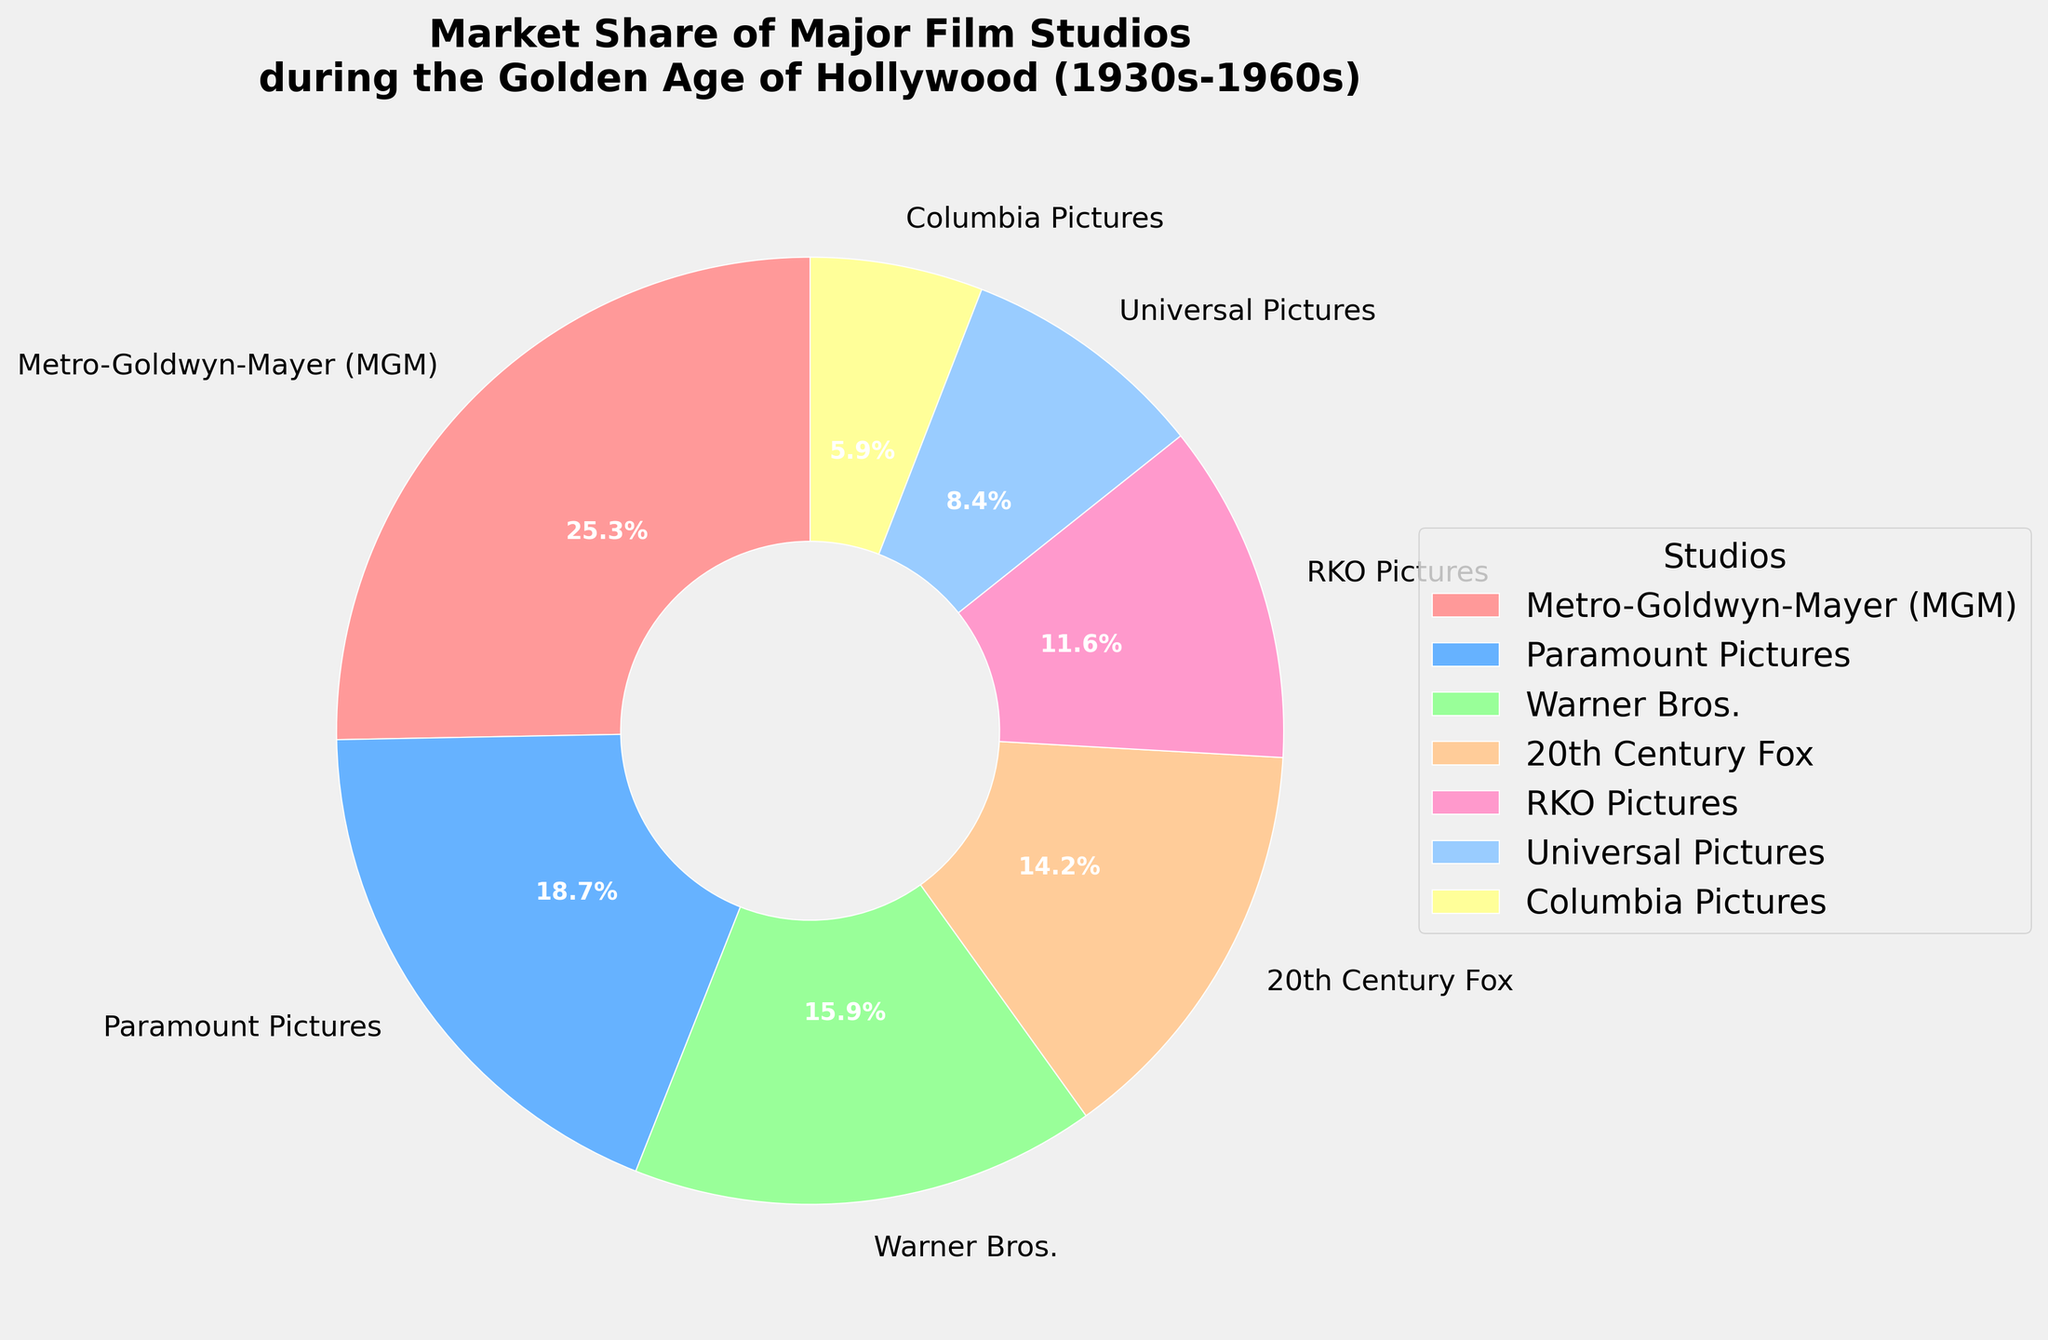Which studio has the largest market share? By observing the labels and percentages on the pie chart, Metro-Goldwyn-Mayer (MGM) has the highest value at 25.3%.
Answer: Metro-Goldwyn-Mayer (MGM) Which two studios combined have a market share greater than 30%? Adding percentages, Metro-Goldwyn-Mayer (25.3%) and Paramount Pictures (18.7%) together give 44%, which is more than 30%.
Answer: Metro-Goldwyn-Mayer (MGM) and Paramount Pictures Which studio has a smaller market share than RKO Pictures but more than Columbia Pictures? Comparing the percentages, we see that Universal Pictures (8.4%) fits between RKO Pictures (11.6%) and Columbia Pictures (5.9%).
Answer: Universal Pictures How many studios have a market share less than 10%? Universal Pictures (8.4%) and Columbia Pictures (5.9%) are both under 10%.
Answer: 2 What is the combined market share of Warner Bros. and 20th Century Fox? Adding Warner Bros. (15.9%) and 20th Century Fox (14.2%) results in 30.1%.
Answer: 30.1% What is the difference in market share between the largest and smallest studios? Subtracting the smallest studio Columbia Pictures (5.9%) from the largest, Metro-Goldwyn-Mayer (25.3%), gives 19.4%.
Answer: 19.4% Which studio is represented by a green color section? Observing the color, the green section corresponds to 20th Century Fox.
Answer: 20th Century Fox Which two studios together represent roughly a third of the total market share? Adding 20th Century Fox (14.2%) and RKO Pictures (11.6%) gives 25.8%, close to one-third. Paramount Pictures (18.7%) and Columbia Pictures (5.9%) sum up to 24.6%. The total market (100%) divided by three is approximately 33.3%.
Answer: Metro-Goldwyn-Mayer (MGM) and 20th Century Fox What percent larger is Metro-Goldwyn-Mayer's market share compared to Warner Bros.'? Subtracting Warner Bros. (15.9%) from Metro-Goldwyn-Mayer (25.3%) and then dividing the result (9.4%) by Warner Bros. share gives 59.1%.
Answer: 59.1% 